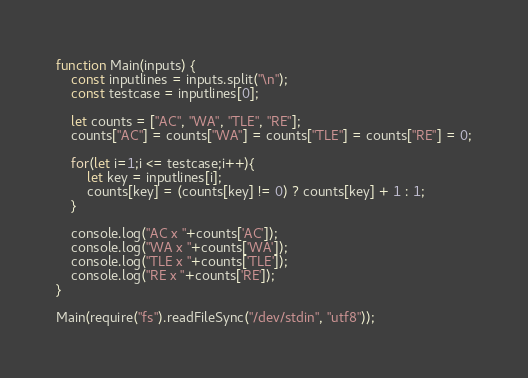<code> <loc_0><loc_0><loc_500><loc_500><_JavaScript_>function Main(inputs) {
	const inputlines = inputs.split("\n");
 	const testcase = inputlines[0];
  
  	let counts = ["AC", "WA", "TLE", "RE"];
  	counts["AC"] = counts["WA"] = counts["TLE"] = counts["RE"] = 0;
  
	for(let i=1;i <= testcase;i++){
  		let key = inputlines[i];
  		counts[key] = (counts[key] != 0) ? counts[key] + 1 : 1;
	}
  
  	console.log("AC x "+counts['AC']);
	console.log("WA x "+counts['WA']);
  	console.log("TLE x "+counts['TLE']);
  	console.log("RE x "+counts['RE']);
}
 
Main(require("fs").readFileSync("/dev/stdin", "utf8"));</code> 